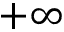Convert formula to latex. <formula><loc_0><loc_0><loc_500><loc_500>+ \infty</formula> 